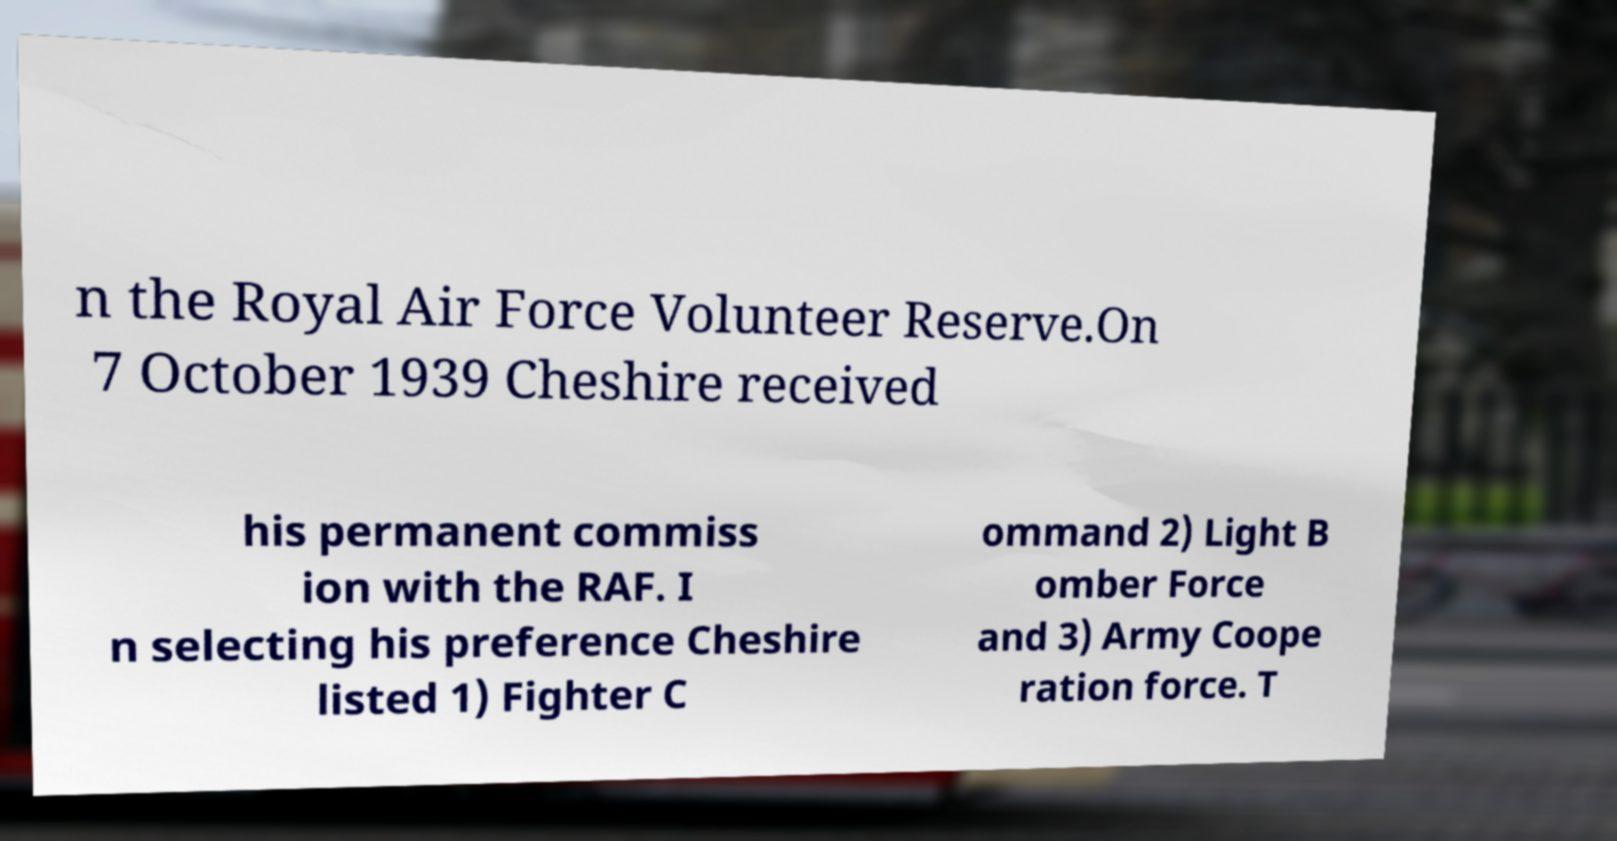Can you read and provide the text displayed in the image?This photo seems to have some interesting text. Can you extract and type it out for me? n the Royal Air Force Volunteer Reserve.On 7 October 1939 Cheshire received his permanent commiss ion with the RAF. I n selecting his preference Cheshire listed 1) Fighter C ommand 2) Light B omber Force and 3) Army Coope ration force. T 